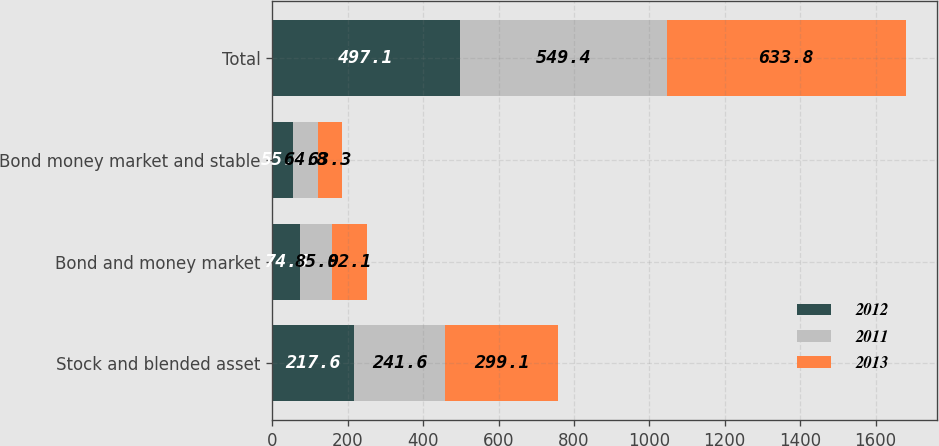Convert chart to OTSL. <chart><loc_0><loc_0><loc_500><loc_500><stacked_bar_chart><ecel><fcel>Stock and blended asset<fcel>Bond and money market<fcel>Bond money market and stable<fcel>Total<nl><fcel>2012<fcel>217.6<fcel>74.5<fcel>55.4<fcel>497.1<nl><fcel>2011<fcel>241.6<fcel>85<fcel>64.8<fcel>549.4<nl><fcel>2013<fcel>299.1<fcel>92.1<fcel>63.3<fcel>633.8<nl></chart> 